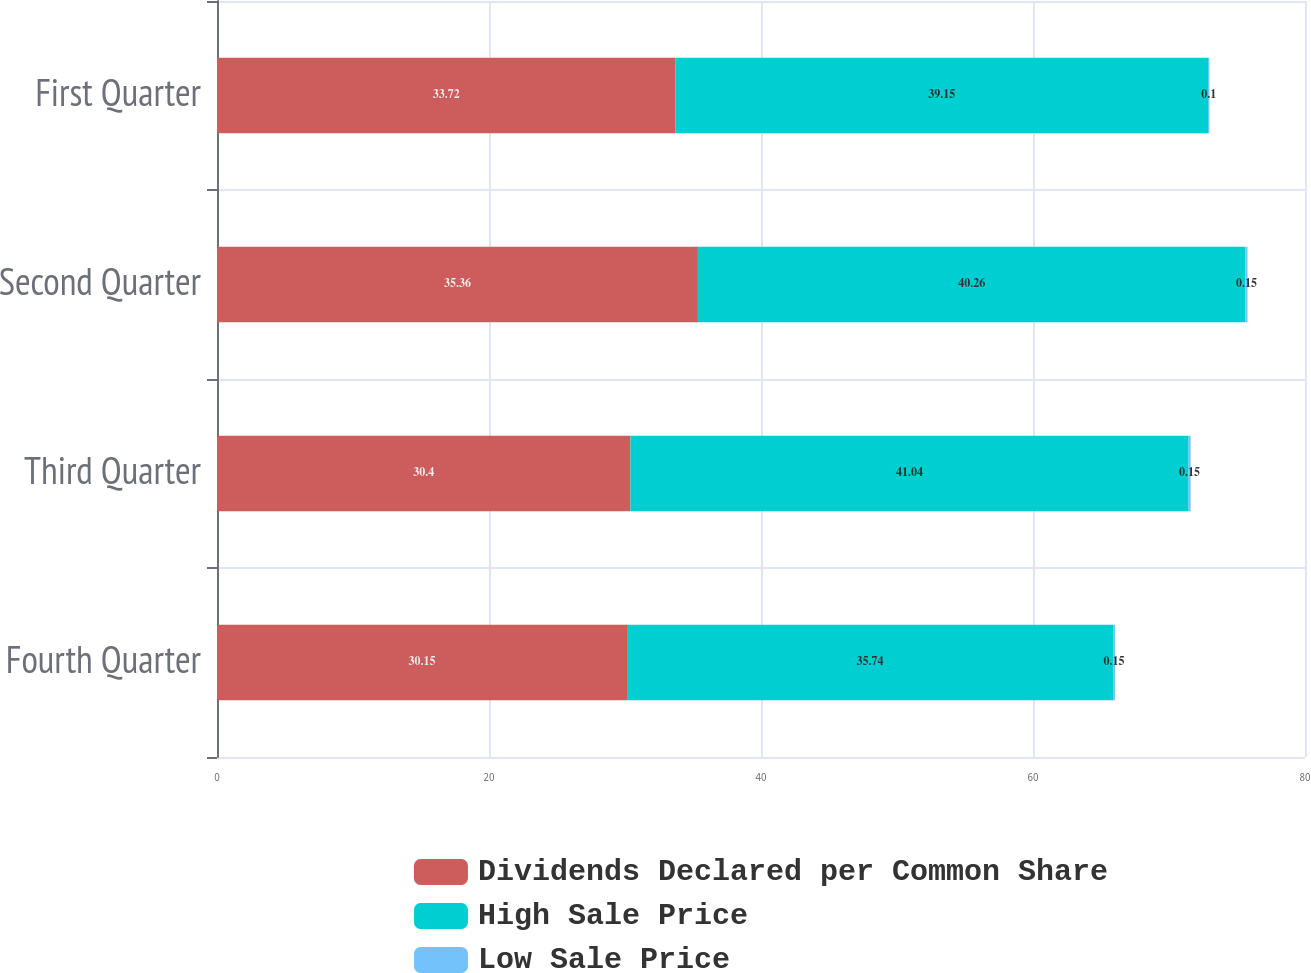<chart> <loc_0><loc_0><loc_500><loc_500><stacked_bar_chart><ecel><fcel>Fourth Quarter<fcel>Third Quarter<fcel>Second Quarter<fcel>First Quarter<nl><fcel>Dividends Declared per Common Share<fcel>30.15<fcel>30.4<fcel>35.36<fcel>33.72<nl><fcel>High Sale Price<fcel>35.74<fcel>41.04<fcel>40.26<fcel>39.15<nl><fcel>Low Sale Price<fcel>0.15<fcel>0.15<fcel>0.15<fcel>0.1<nl></chart> 